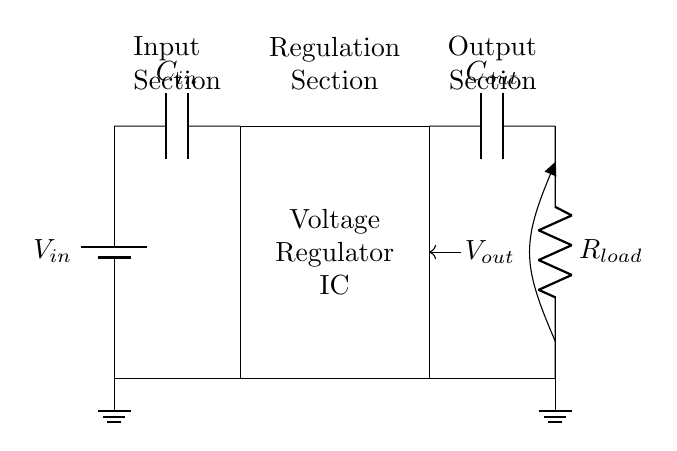What is the input component of the circuit? The input component is a battery, designated as V in. It provides the necessary voltage for the circuit to operate.
Answer: battery What does the voltage regulator IC do? The voltage regulator IC stabilizes the output voltage to a specific level while managing variations in the input voltage and load conditions.
Answer: stabilizes voltage What is the purpose of C in? C in is the input capacitor that smooths out voltage variations from the battery by filtering noise and providing a stable voltage to the regulator.
Answer: smoothing What is the output across R load? The output voltage V out is measured across the load resistor R load. It represents the voltage supplied to the connected load.
Answer: V out How is feedback achieved in this circuit? Feedback is achieved through a connection from the output (V out) back to the voltage regulator IC, helping it to regulate the output voltage effectively by adjusting its behavior based on output conditions.
Answer: feedback loop What type of circuit is this? This is a voltage regulator circuit specifically designed for portable electronics, aimed at maintaining consistent voltage levels despite variations in input or load.
Answer: voltage regulator What role does C out play? C out is the output capacitor, which smooths the output voltage and helps reduce ripple, ensuring a clean and stable voltage supply to the load.
Answer: filtering 